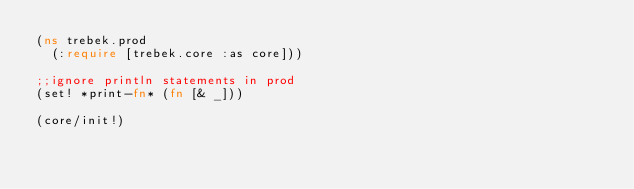Convert code to text. <code><loc_0><loc_0><loc_500><loc_500><_Clojure_>(ns trebek.prod
  (:require [trebek.core :as core]))

;;ignore println statements in prod
(set! *print-fn* (fn [& _]))

(core/init!)
</code> 